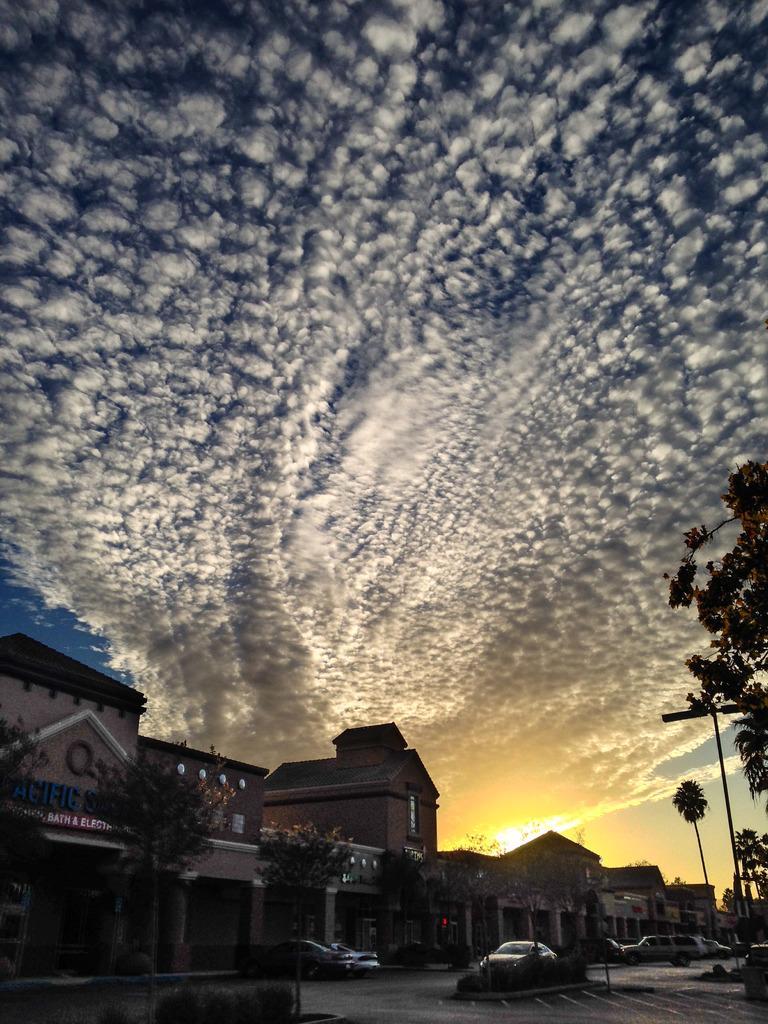In one or two sentences, can you explain what this image depicts? In this image we can see the clouds in the sky. And we can see the many buildings. And we can see the trees. And we can see the vehicles on the road. 